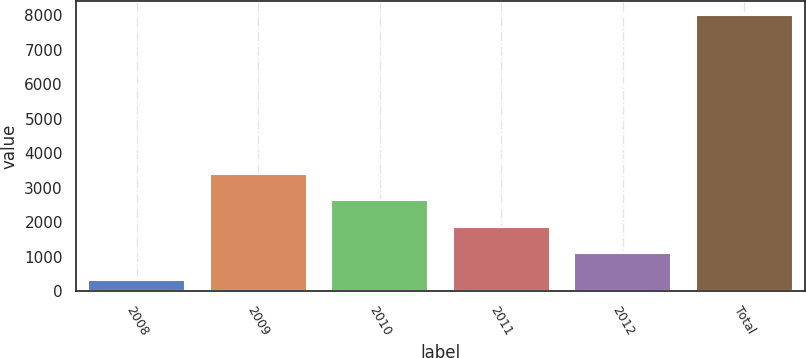Convert chart. <chart><loc_0><loc_0><loc_500><loc_500><bar_chart><fcel>2008<fcel>2009<fcel>2010<fcel>2011<fcel>2012<fcel>Total<nl><fcel>329<fcel>3407.8<fcel>2638.1<fcel>1868.4<fcel>1098.7<fcel>8026<nl></chart> 